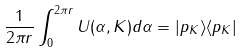Convert formula to latex. <formula><loc_0><loc_0><loc_500><loc_500>\frac { 1 } { 2 \pi r } \int ^ { 2 \pi r } _ { 0 } U ( \alpha , K ) d \alpha = | p _ { K } \rangle \langle p _ { K } |</formula> 